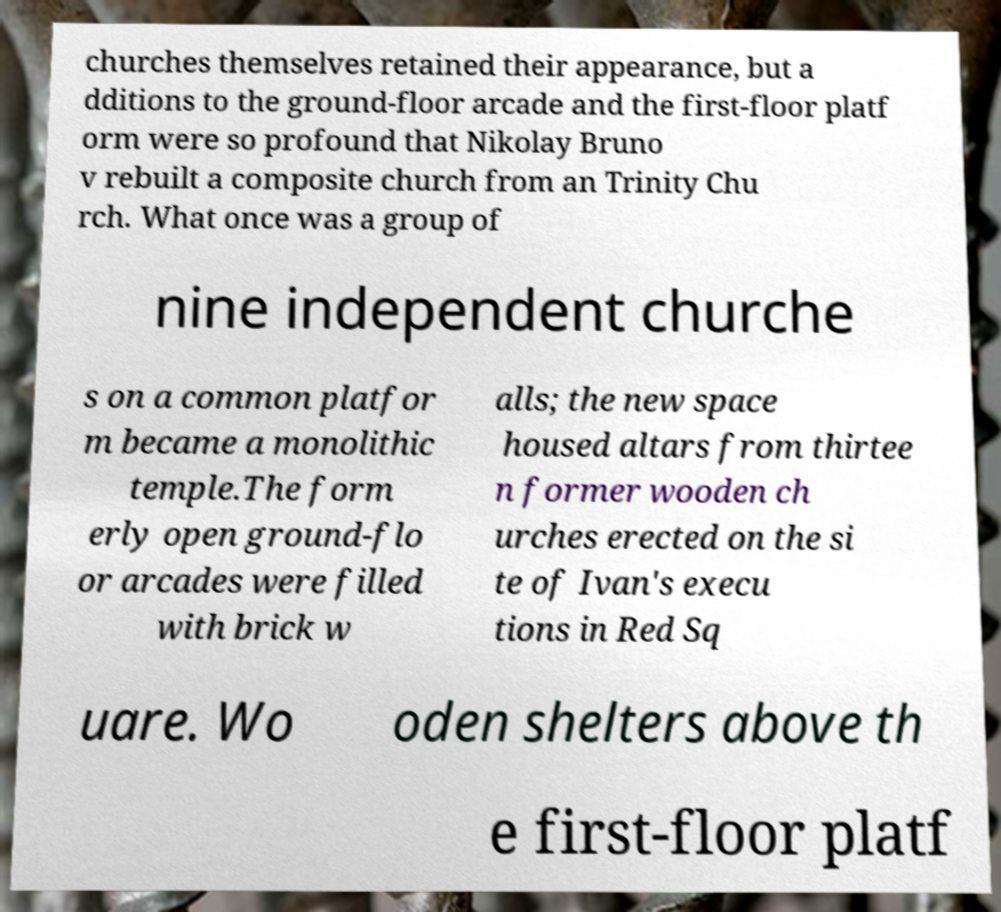For documentation purposes, I need the text within this image transcribed. Could you provide that? churches themselves retained their appearance, but a dditions to the ground-floor arcade and the first-floor platf orm were so profound that Nikolay Bruno v rebuilt a composite church from an Trinity Chu rch. What once was a group of nine independent churche s on a common platfor m became a monolithic temple.The form erly open ground-flo or arcades were filled with brick w alls; the new space housed altars from thirtee n former wooden ch urches erected on the si te of Ivan's execu tions in Red Sq uare. Wo oden shelters above th e first-floor platf 